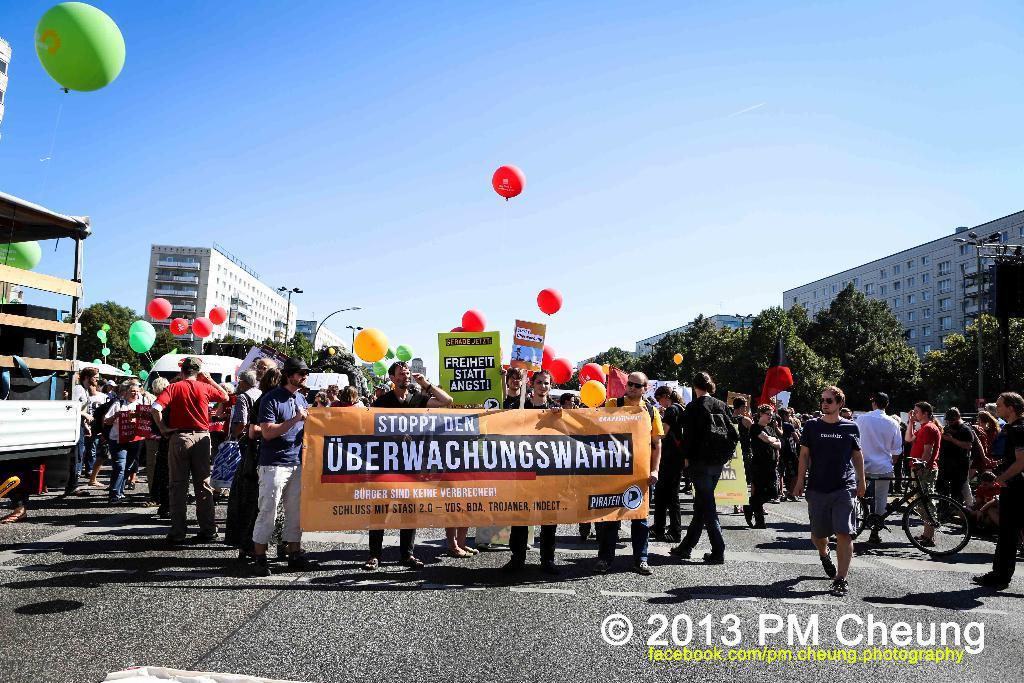Could you give a brief overview of what you see in this image? In this image I can see the group of people standing on the road. These people are wearing the different color dresses and few people are holding the banner and boards. I can see many vehicles and colorful balloons. I can also see many trees and buildings to the side of the road. In the background there is a sky. 